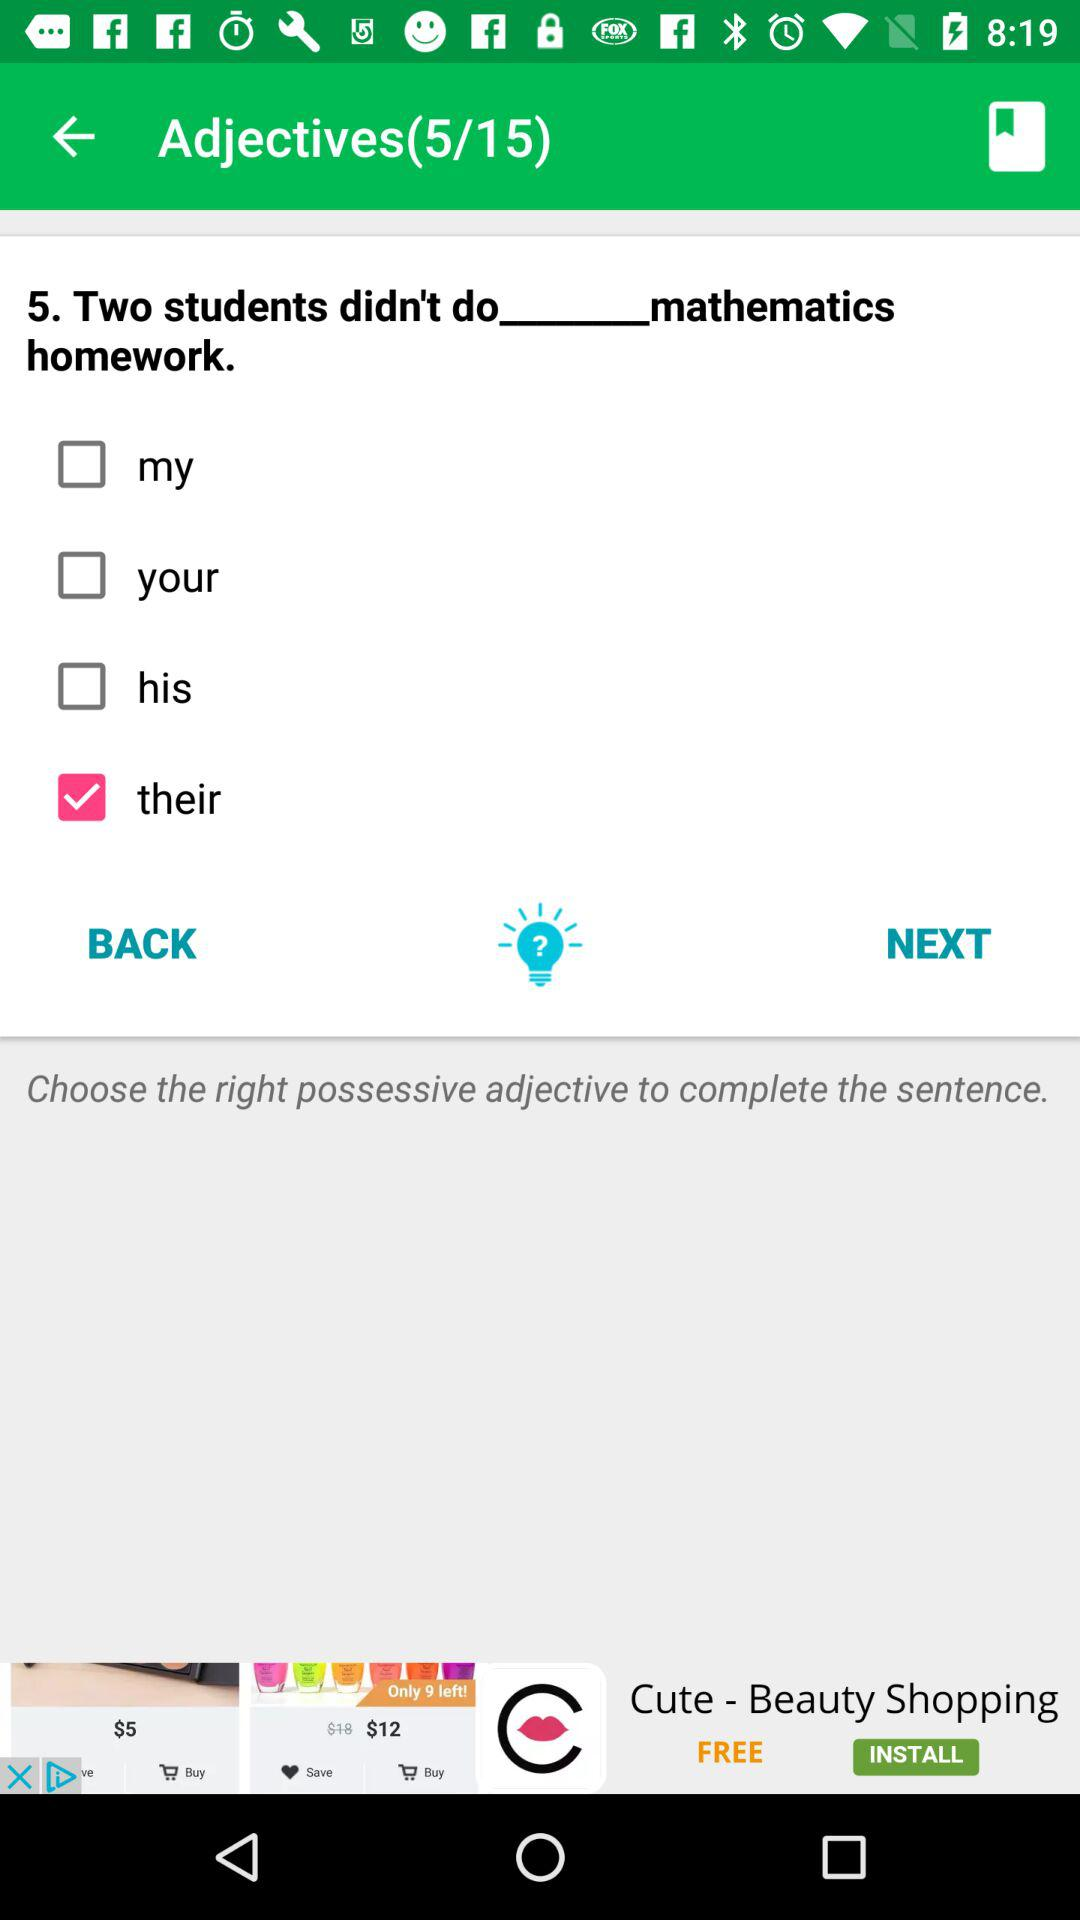At which question am I? You are at question 5. 